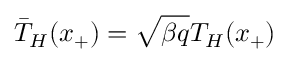<formula> <loc_0><loc_0><loc_500><loc_500>\bar { T } _ { H } ( x _ { + } ) = \sqrt { \beta q } T _ { H } ( x _ { + } )</formula> 